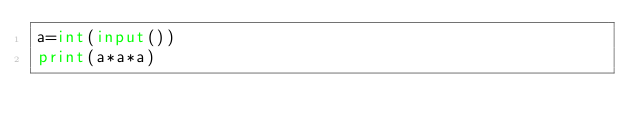<code> <loc_0><loc_0><loc_500><loc_500><_Python_>a=int(input())
print(a*a*a)
</code> 